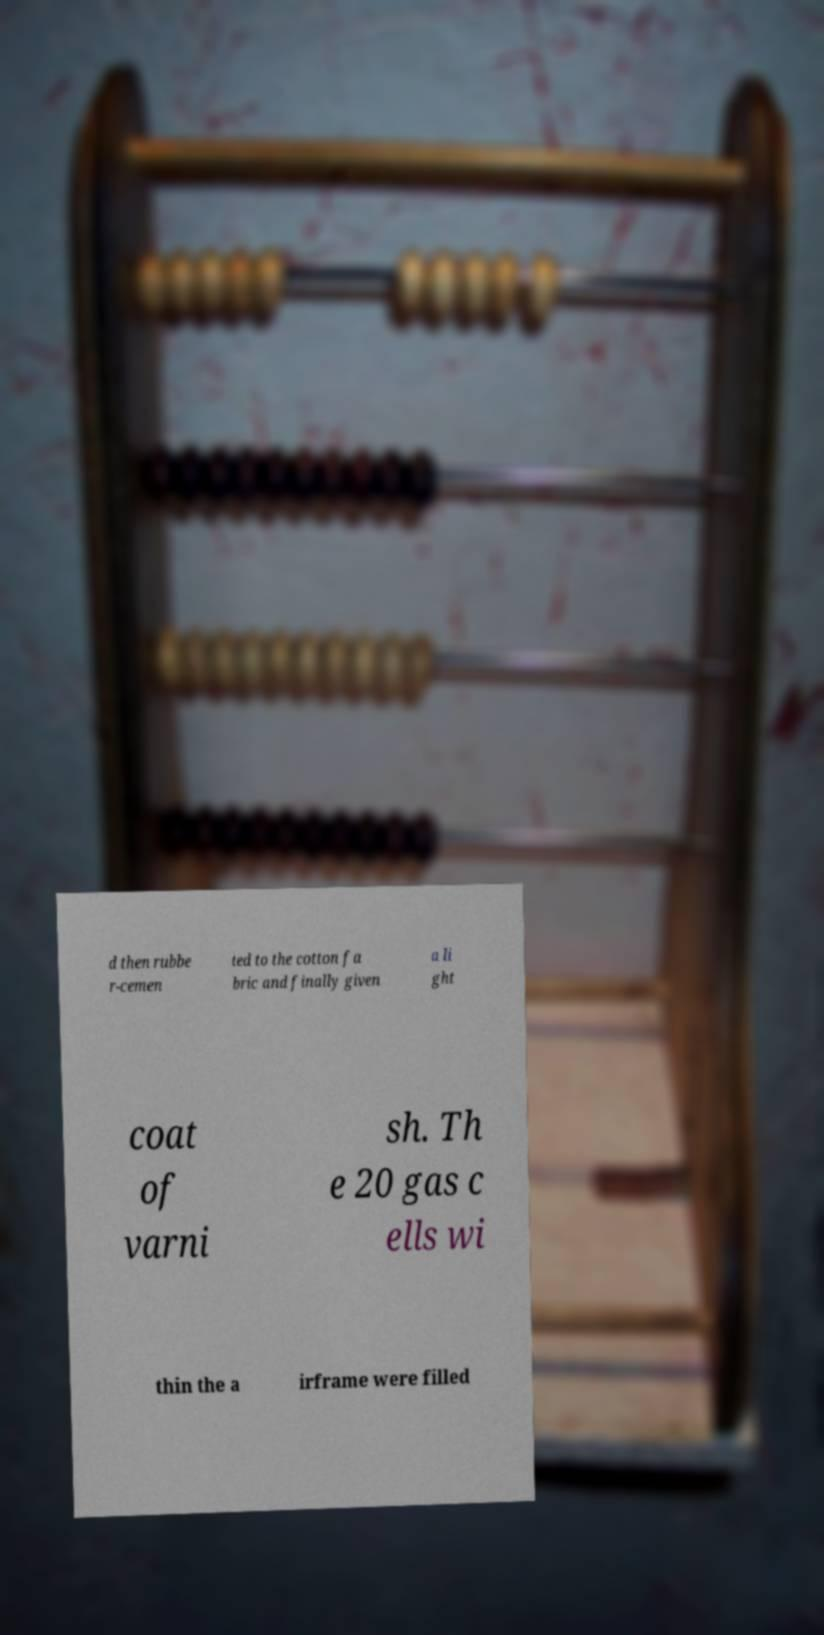There's text embedded in this image that I need extracted. Can you transcribe it verbatim? d then rubbe r-cemen ted to the cotton fa bric and finally given a li ght coat of varni sh. Th e 20 gas c ells wi thin the a irframe were filled 